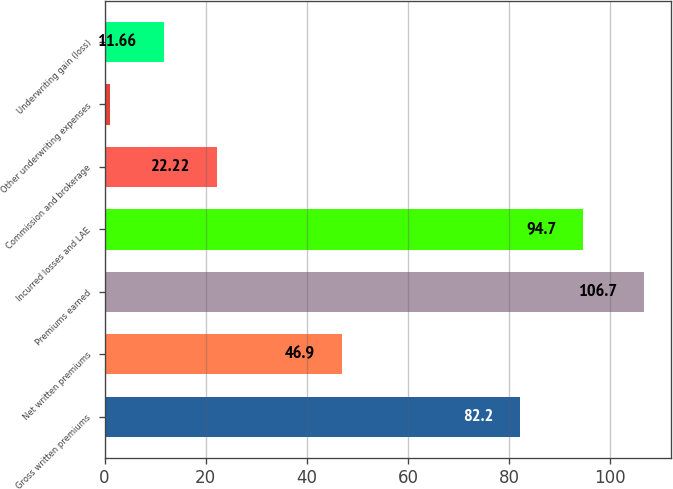Convert chart. <chart><loc_0><loc_0><loc_500><loc_500><bar_chart><fcel>Gross written premiums<fcel>Net written premiums<fcel>Premiums earned<fcel>Incurred losses and LAE<fcel>Commission and brokerage<fcel>Other underwriting expenses<fcel>Underwriting gain (loss)<nl><fcel>82.2<fcel>46.9<fcel>106.7<fcel>94.7<fcel>22.22<fcel>1.1<fcel>11.66<nl></chart> 